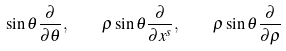<formula> <loc_0><loc_0><loc_500><loc_500>\sin \theta \frac { \partial } { \partial \theta } , \quad \rho \sin \theta \frac { \partial } { \partial x ^ { s } } , \quad \rho \sin \theta \frac { \partial } { \partial \rho }</formula> 